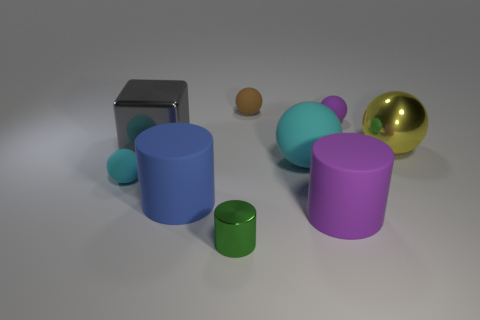Are there any other things that are the same material as the small cyan thing?
Your answer should be very brief. Yes. There is a yellow object that is the same shape as the tiny purple rubber object; what is its material?
Ensure brevity in your answer.  Metal. Is the number of tiny brown matte things left of the green metal object less than the number of tiny purple shiny cylinders?
Ensure brevity in your answer.  No. There is a large purple cylinder; what number of tiny rubber spheres are on the right side of it?
Offer a terse response. 1. Is the shape of the cyan thing that is left of the brown thing the same as the big object behind the large yellow sphere?
Keep it short and to the point. No. There is a small object that is to the right of the gray metal thing and in front of the yellow shiny object; what is its shape?
Provide a short and direct response. Cylinder. The blue thing that is made of the same material as the small brown sphere is what size?
Your response must be concise. Large. Are there fewer small rubber objects than red cylinders?
Your answer should be compact. No. The purple thing in front of the cyan rubber sphere that is on the right side of the cyan rubber thing that is on the left side of the large gray metallic thing is made of what material?
Provide a short and direct response. Rubber. Is the large sphere left of the yellow object made of the same material as the big purple cylinder that is behind the green metallic cylinder?
Offer a very short reply. Yes. 